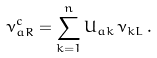<formula> <loc_0><loc_0><loc_500><loc_500>\nu _ { a R } ^ { c } = \sum _ { k = 1 } ^ { n } U _ { a k } \, \nu _ { k L } \, .</formula> 